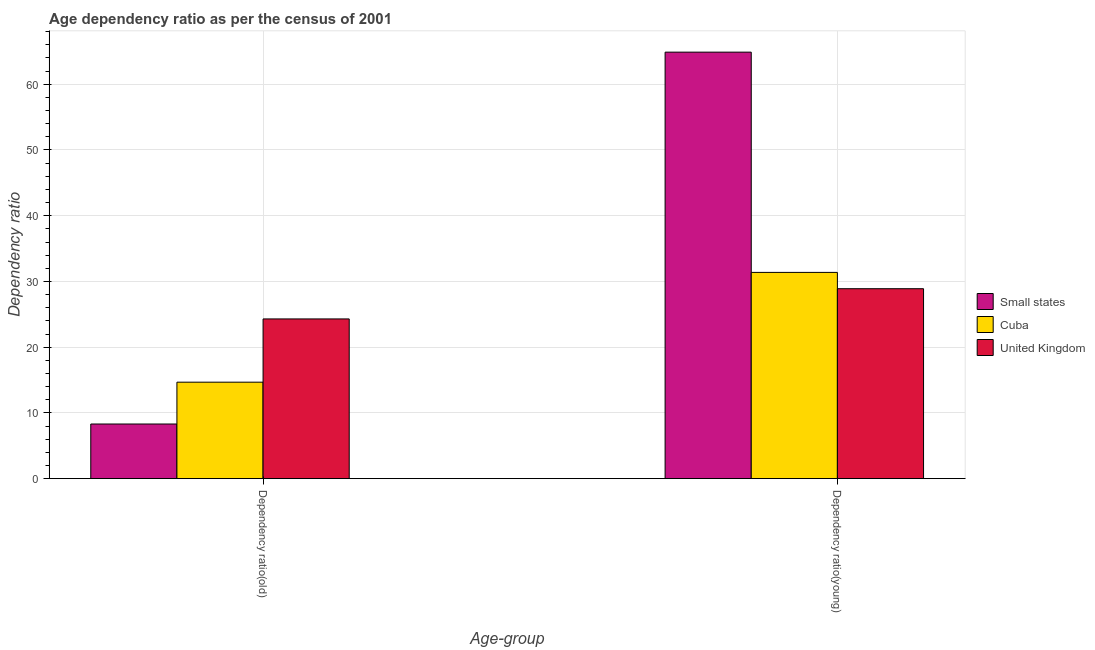How many groups of bars are there?
Ensure brevity in your answer.  2. Are the number of bars per tick equal to the number of legend labels?
Ensure brevity in your answer.  Yes. Are the number of bars on each tick of the X-axis equal?
Provide a short and direct response. Yes. What is the label of the 2nd group of bars from the left?
Ensure brevity in your answer.  Dependency ratio(young). What is the age dependency ratio(young) in United Kingdom?
Your answer should be compact. 28.89. Across all countries, what is the maximum age dependency ratio(old)?
Ensure brevity in your answer.  24.3. Across all countries, what is the minimum age dependency ratio(young)?
Offer a very short reply. 28.89. In which country was the age dependency ratio(old) minimum?
Your response must be concise. Small states. What is the total age dependency ratio(young) in the graph?
Give a very brief answer. 125.16. What is the difference between the age dependency ratio(young) in Small states and that in Cuba?
Make the answer very short. 33.51. What is the difference between the age dependency ratio(young) in Small states and the age dependency ratio(old) in Cuba?
Give a very brief answer. 50.21. What is the average age dependency ratio(young) per country?
Your response must be concise. 41.72. What is the difference between the age dependency ratio(old) and age dependency ratio(young) in United Kingdom?
Give a very brief answer. -4.6. In how many countries, is the age dependency ratio(young) greater than 12 ?
Ensure brevity in your answer.  3. What is the ratio of the age dependency ratio(old) in Cuba to that in United Kingdom?
Ensure brevity in your answer.  0.6. Is the age dependency ratio(young) in United Kingdom less than that in Small states?
Provide a succinct answer. Yes. What does the 2nd bar from the left in Dependency ratio(old) represents?
Your answer should be very brief. Cuba. What does the 3rd bar from the right in Dependency ratio(young) represents?
Your response must be concise. Small states. How many bars are there?
Make the answer very short. 6. How many countries are there in the graph?
Keep it short and to the point. 3. What is the difference between two consecutive major ticks on the Y-axis?
Keep it short and to the point. 10. Does the graph contain any zero values?
Give a very brief answer. No. How many legend labels are there?
Ensure brevity in your answer.  3. How are the legend labels stacked?
Your response must be concise. Vertical. What is the title of the graph?
Your response must be concise. Age dependency ratio as per the census of 2001. What is the label or title of the X-axis?
Provide a short and direct response. Age-group. What is the label or title of the Y-axis?
Provide a succinct answer. Dependency ratio. What is the Dependency ratio of Small states in Dependency ratio(old)?
Offer a terse response. 8.31. What is the Dependency ratio of Cuba in Dependency ratio(old)?
Offer a very short reply. 14.67. What is the Dependency ratio in United Kingdom in Dependency ratio(old)?
Provide a short and direct response. 24.3. What is the Dependency ratio of Small states in Dependency ratio(young)?
Provide a succinct answer. 64.89. What is the Dependency ratio of Cuba in Dependency ratio(young)?
Ensure brevity in your answer.  31.37. What is the Dependency ratio of United Kingdom in Dependency ratio(young)?
Provide a short and direct response. 28.89. Across all Age-group, what is the maximum Dependency ratio in Small states?
Your answer should be compact. 64.89. Across all Age-group, what is the maximum Dependency ratio in Cuba?
Ensure brevity in your answer.  31.37. Across all Age-group, what is the maximum Dependency ratio in United Kingdom?
Your response must be concise. 28.89. Across all Age-group, what is the minimum Dependency ratio of Small states?
Offer a very short reply. 8.31. Across all Age-group, what is the minimum Dependency ratio in Cuba?
Give a very brief answer. 14.67. Across all Age-group, what is the minimum Dependency ratio of United Kingdom?
Provide a succinct answer. 24.3. What is the total Dependency ratio in Small states in the graph?
Offer a terse response. 73.19. What is the total Dependency ratio of Cuba in the graph?
Provide a succinct answer. 46.05. What is the total Dependency ratio in United Kingdom in the graph?
Offer a terse response. 53.19. What is the difference between the Dependency ratio in Small states in Dependency ratio(old) and that in Dependency ratio(young)?
Ensure brevity in your answer.  -56.58. What is the difference between the Dependency ratio of Cuba in Dependency ratio(old) and that in Dependency ratio(young)?
Provide a short and direct response. -16.7. What is the difference between the Dependency ratio in United Kingdom in Dependency ratio(old) and that in Dependency ratio(young)?
Keep it short and to the point. -4.6. What is the difference between the Dependency ratio of Small states in Dependency ratio(old) and the Dependency ratio of Cuba in Dependency ratio(young)?
Make the answer very short. -23.07. What is the difference between the Dependency ratio of Small states in Dependency ratio(old) and the Dependency ratio of United Kingdom in Dependency ratio(young)?
Provide a succinct answer. -20.59. What is the difference between the Dependency ratio in Cuba in Dependency ratio(old) and the Dependency ratio in United Kingdom in Dependency ratio(young)?
Provide a short and direct response. -14.22. What is the average Dependency ratio of Small states per Age-group?
Ensure brevity in your answer.  36.6. What is the average Dependency ratio of Cuba per Age-group?
Offer a terse response. 23.02. What is the average Dependency ratio in United Kingdom per Age-group?
Your response must be concise. 26.6. What is the difference between the Dependency ratio of Small states and Dependency ratio of Cuba in Dependency ratio(old)?
Keep it short and to the point. -6.36. What is the difference between the Dependency ratio in Small states and Dependency ratio in United Kingdom in Dependency ratio(old)?
Provide a short and direct response. -15.99. What is the difference between the Dependency ratio in Cuba and Dependency ratio in United Kingdom in Dependency ratio(old)?
Offer a terse response. -9.62. What is the difference between the Dependency ratio in Small states and Dependency ratio in Cuba in Dependency ratio(young)?
Your answer should be compact. 33.51. What is the difference between the Dependency ratio in Small states and Dependency ratio in United Kingdom in Dependency ratio(young)?
Provide a succinct answer. 35.99. What is the difference between the Dependency ratio of Cuba and Dependency ratio of United Kingdom in Dependency ratio(young)?
Offer a very short reply. 2.48. What is the ratio of the Dependency ratio of Small states in Dependency ratio(old) to that in Dependency ratio(young)?
Ensure brevity in your answer.  0.13. What is the ratio of the Dependency ratio in Cuba in Dependency ratio(old) to that in Dependency ratio(young)?
Ensure brevity in your answer.  0.47. What is the ratio of the Dependency ratio in United Kingdom in Dependency ratio(old) to that in Dependency ratio(young)?
Keep it short and to the point. 0.84. What is the difference between the highest and the second highest Dependency ratio of Small states?
Provide a short and direct response. 56.58. What is the difference between the highest and the second highest Dependency ratio in Cuba?
Offer a terse response. 16.7. What is the difference between the highest and the second highest Dependency ratio of United Kingdom?
Offer a terse response. 4.6. What is the difference between the highest and the lowest Dependency ratio in Small states?
Provide a short and direct response. 56.58. What is the difference between the highest and the lowest Dependency ratio of Cuba?
Provide a succinct answer. 16.7. What is the difference between the highest and the lowest Dependency ratio of United Kingdom?
Your answer should be compact. 4.6. 